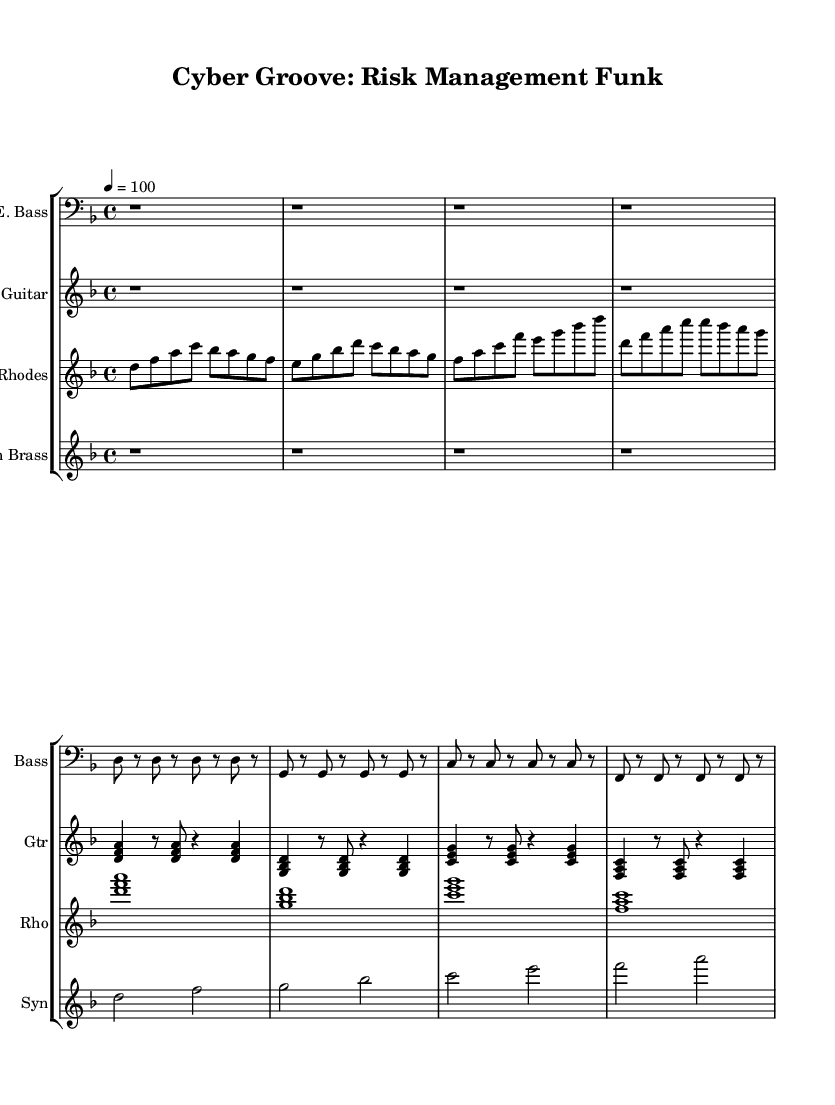What is the key signature of this music? The key signature is D minor, which has one flat (B flat). You can determine the key signature by looking at the beginning of the music where it shows the key signature symbols before the first staff line.
Answer: D minor What is the time signature of this music? The time signature is 4/4, meaning there are four beats in each measure, and each quarter note receives one beat. This is indicated at the beginning of the score.
Answer: 4/4 What is the tempo marking in this piece? The tempo marking is "4 = 100," indicating that there are 100 beats per minute for a quarter note. This shows the speed at which the music should be played.
Answer: 100 How many measures are there in the electric bass part? The electric bass part consists of 8 measures, each measure is divided by vertical lines in the notation. By counting the segments between the bar lines, we find there are 8 total.
Answer: 8 What is the highest note played on the electric guitar? The highest note played on the electric guitar is D, which is found in the chord <g, bes, d>. The D note appears above other notes when looking at the staff.
Answer: D Which instrument has a consistent syncopated rhythm? The Rhodes piano has a consistent syncopated rhythm in its melody line, creating a funk feel throughout the piece. This can be observed by the repeating patterns and rhythmic placements of the notes.
Answer: Rhodes What type of musical texture is primarily used in this piece? The piece predominantly utilizes a polyphonic texture, where multiple independent melodies and harmonies are played simultaneously across the different instruments, typical in funk music. This can be identified through overlapping melodies between the instruments.
Answer: Polyphonic 